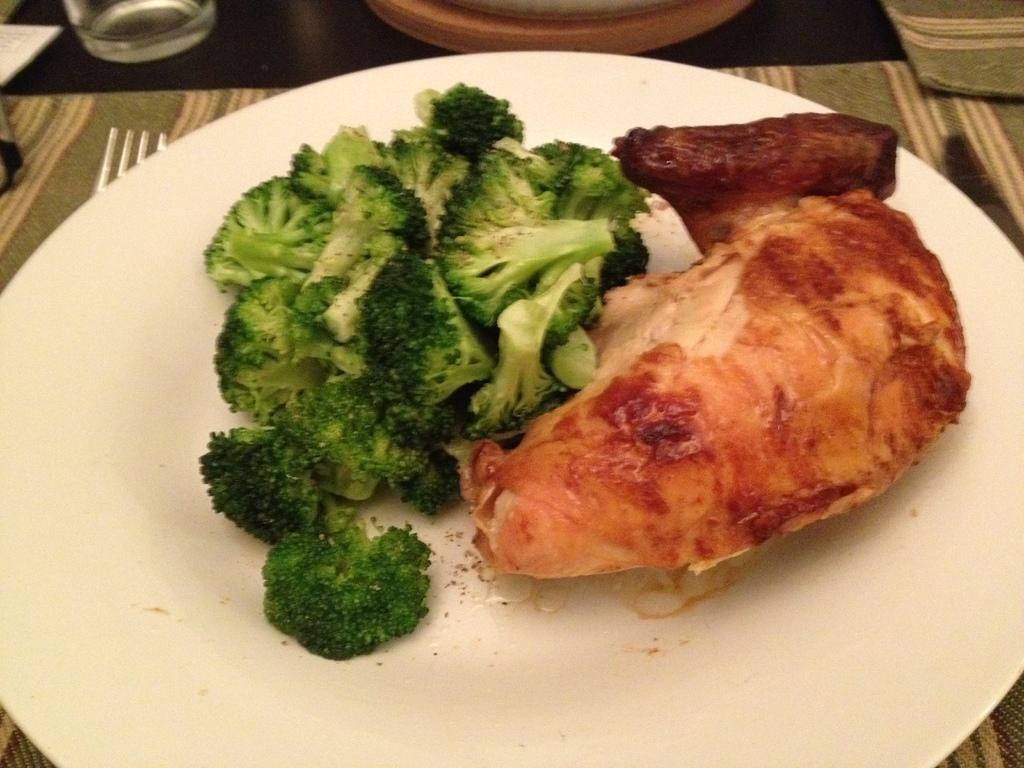What is on the plate that is visible in the image? There is a food item on the plate in the image. Where is the plate located in the image? The plate is placed on a table in the image. What utensil is present on the table in the image? There is a fork on the table in the image. What type of container is on the table in the image? There is a glass on the table in the image. What type of print can be seen on the zebra in the image? There is no zebra present in the image; it only features a plate with a food item, a fork, a glass, and a table. 